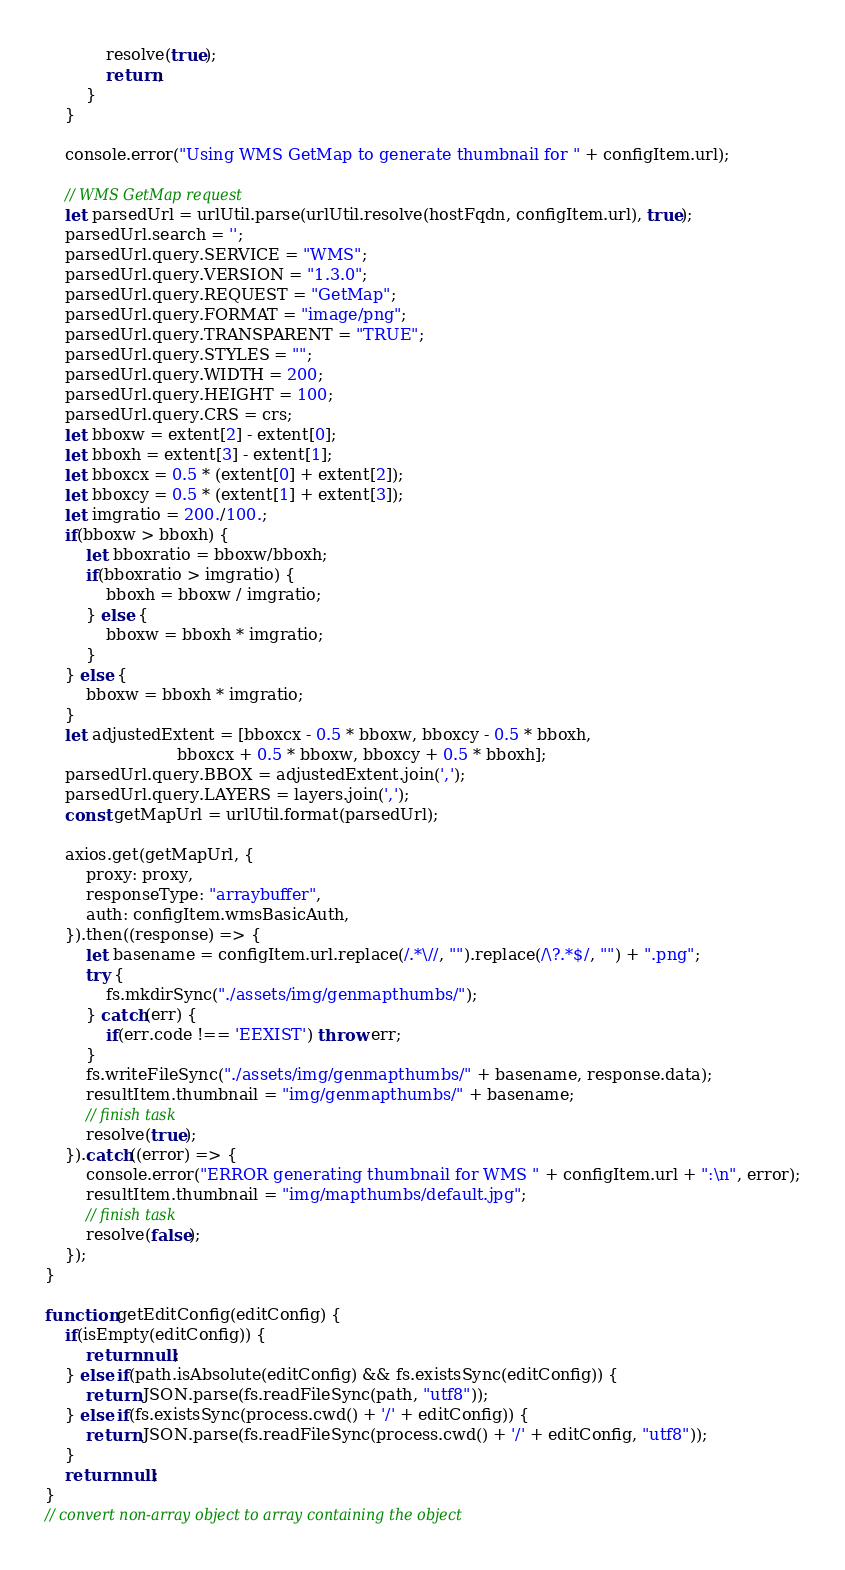<code> <loc_0><loc_0><loc_500><loc_500><_JavaScript_>            resolve(true);
            return;
        }
    }

    console.error("Using WMS GetMap to generate thumbnail for " + configItem.url);

    // WMS GetMap request
    let parsedUrl = urlUtil.parse(urlUtil.resolve(hostFqdn, configItem.url), true);
    parsedUrl.search = '';
    parsedUrl.query.SERVICE = "WMS";
    parsedUrl.query.VERSION = "1.3.0";
    parsedUrl.query.REQUEST = "GetMap";
    parsedUrl.query.FORMAT = "image/png";
    parsedUrl.query.TRANSPARENT = "TRUE";
    parsedUrl.query.STYLES = "";
    parsedUrl.query.WIDTH = 200;
    parsedUrl.query.HEIGHT = 100;
    parsedUrl.query.CRS = crs;
    let bboxw = extent[2] - extent[0];
    let bboxh = extent[3] - extent[1];
    let bboxcx = 0.5 * (extent[0] + extent[2]);
    let bboxcy = 0.5 * (extent[1] + extent[3]);
    let imgratio = 200./100.;
    if(bboxw > bboxh) {
        let bboxratio = bboxw/bboxh;
        if(bboxratio > imgratio) {
            bboxh = bboxw / imgratio;
        } else {
            bboxw = bboxh * imgratio;
        }
    } else {
        bboxw = bboxh * imgratio;
    }
    let adjustedExtent = [bboxcx - 0.5 * bboxw, bboxcy - 0.5 * bboxh,
                          bboxcx + 0.5 * bboxw, bboxcy + 0.5 * bboxh];
    parsedUrl.query.BBOX = adjustedExtent.join(',');
    parsedUrl.query.LAYERS = layers.join(',');
    const getMapUrl = urlUtil.format(parsedUrl);

    axios.get(getMapUrl, {
        proxy: proxy,
        responseType: "arraybuffer",
        auth: configItem.wmsBasicAuth,
    }).then((response) => {
        let basename = configItem.url.replace(/.*\//, "").replace(/\?.*$/, "") + ".png";
        try {
            fs.mkdirSync("./assets/img/genmapthumbs/");
        } catch(err) {
            if(err.code !== 'EEXIST') throw err;
        }
        fs.writeFileSync("./assets/img/genmapthumbs/" + basename, response.data);
        resultItem.thumbnail = "img/genmapthumbs/" + basename;
        // finish task
        resolve(true);
    }).catch((error) => {
        console.error("ERROR generating thumbnail for WMS " + configItem.url + ":\n", error);
        resultItem.thumbnail = "img/mapthumbs/default.jpg";
        // finish task
        resolve(false);
    });
}

function getEditConfig(editConfig) {
    if(isEmpty(editConfig)) {
        return null;
    } else if(path.isAbsolute(editConfig) && fs.existsSync(editConfig)) {
        return JSON.parse(fs.readFileSync(path, "utf8"));
    } else if(fs.existsSync(process.cwd() + '/' + editConfig)) {
        return JSON.parse(fs.readFileSync(process.cwd() + '/' + editConfig, "utf8"));
    }
    return null;
}
// convert non-array object to array containing the object</code> 